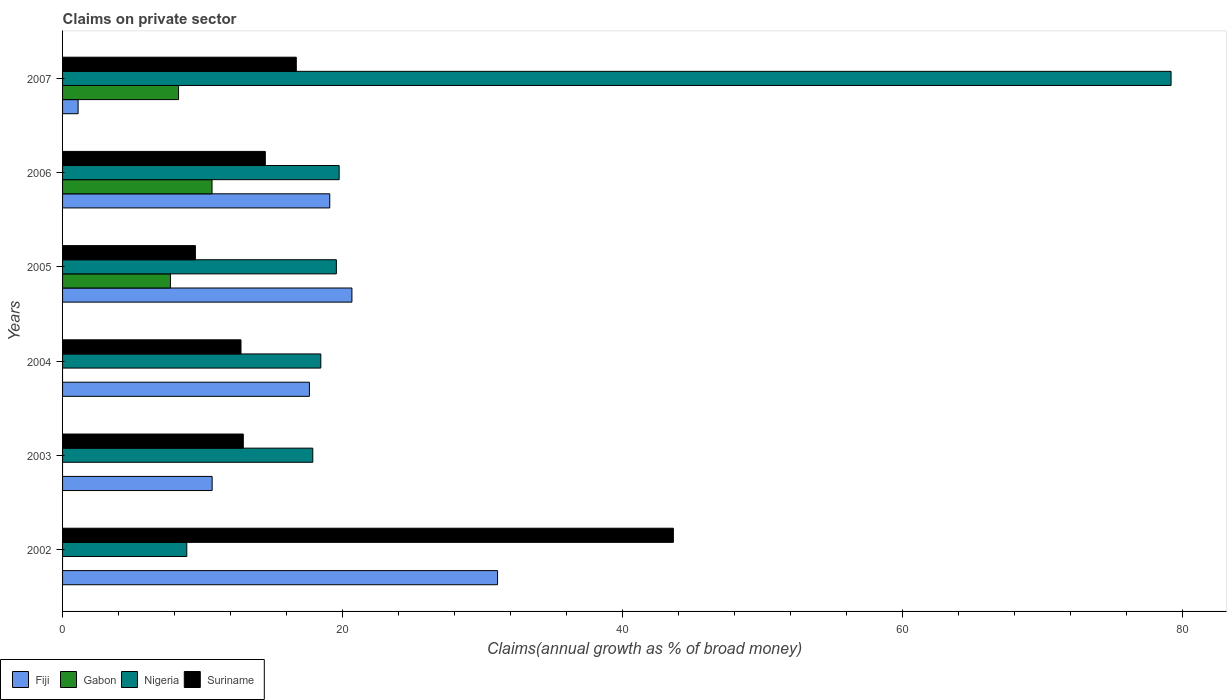How many different coloured bars are there?
Provide a short and direct response. 4. How many groups of bars are there?
Make the answer very short. 6. Are the number of bars per tick equal to the number of legend labels?
Ensure brevity in your answer.  No. Are the number of bars on each tick of the Y-axis equal?
Offer a very short reply. No. What is the percentage of broad money claimed on private sector in Suriname in 2007?
Give a very brief answer. 16.69. Across all years, what is the maximum percentage of broad money claimed on private sector in Fiji?
Offer a terse response. 31.07. Across all years, what is the minimum percentage of broad money claimed on private sector in Gabon?
Provide a short and direct response. 0. What is the total percentage of broad money claimed on private sector in Fiji in the graph?
Your answer should be very brief. 100.24. What is the difference between the percentage of broad money claimed on private sector in Fiji in 2004 and that in 2006?
Make the answer very short. -1.45. What is the difference between the percentage of broad money claimed on private sector in Suriname in 2003 and the percentage of broad money claimed on private sector in Fiji in 2002?
Keep it short and to the point. -18.16. What is the average percentage of broad money claimed on private sector in Suriname per year?
Make the answer very short. 18.32. In the year 2006, what is the difference between the percentage of broad money claimed on private sector in Fiji and percentage of broad money claimed on private sector in Suriname?
Provide a succinct answer. 4.6. What is the ratio of the percentage of broad money claimed on private sector in Suriname in 2005 to that in 2007?
Keep it short and to the point. 0.57. Is the percentage of broad money claimed on private sector in Suriname in 2006 less than that in 2007?
Your answer should be very brief. Yes. Is the difference between the percentage of broad money claimed on private sector in Fiji in 2003 and 2004 greater than the difference between the percentage of broad money claimed on private sector in Suriname in 2003 and 2004?
Provide a succinct answer. No. What is the difference between the highest and the second highest percentage of broad money claimed on private sector in Gabon?
Keep it short and to the point. 2.39. What is the difference between the highest and the lowest percentage of broad money claimed on private sector in Gabon?
Make the answer very short. 10.68. Is it the case that in every year, the sum of the percentage of broad money claimed on private sector in Fiji and percentage of broad money claimed on private sector in Nigeria is greater than the sum of percentage of broad money claimed on private sector in Suriname and percentage of broad money claimed on private sector in Gabon?
Give a very brief answer. Yes. How many bars are there?
Your answer should be compact. 21. How many years are there in the graph?
Your answer should be compact. 6. What is the difference between two consecutive major ticks on the X-axis?
Give a very brief answer. 20. Are the values on the major ticks of X-axis written in scientific E-notation?
Offer a terse response. No. How many legend labels are there?
Your response must be concise. 4. How are the legend labels stacked?
Provide a succinct answer. Horizontal. What is the title of the graph?
Make the answer very short. Claims on private sector. Does "Jamaica" appear as one of the legend labels in the graph?
Ensure brevity in your answer.  No. What is the label or title of the X-axis?
Offer a very short reply. Claims(annual growth as % of broad money). What is the label or title of the Y-axis?
Provide a succinct answer. Years. What is the Claims(annual growth as % of broad money) in Fiji in 2002?
Ensure brevity in your answer.  31.07. What is the Claims(annual growth as % of broad money) in Gabon in 2002?
Your response must be concise. 0. What is the Claims(annual growth as % of broad money) in Nigeria in 2002?
Your response must be concise. 8.87. What is the Claims(annual growth as % of broad money) in Suriname in 2002?
Ensure brevity in your answer.  43.63. What is the Claims(annual growth as % of broad money) in Fiji in 2003?
Make the answer very short. 10.68. What is the Claims(annual growth as % of broad money) in Nigeria in 2003?
Your answer should be very brief. 17.87. What is the Claims(annual growth as % of broad money) of Suriname in 2003?
Your answer should be compact. 12.91. What is the Claims(annual growth as % of broad money) of Fiji in 2004?
Your answer should be compact. 17.63. What is the Claims(annual growth as % of broad money) of Nigeria in 2004?
Your response must be concise. 18.44. What is the Claims(annual growth as % of broad money) of Suriname in 2004?
Keep it short and to the point. 12.74. What is the Claims(annual growth as % of broad money) of Fiji in 2005?
Provide a succinct answer. 20.67. What is the Claims(annual growth as % of broad money) of Gabon in 2005?
Your response must be concise. 7.7. What is the Claims(annual growth as % of broad money) of Nigeria in 2005?
Make the answer very short. 19.56. What is the Claims(annual growth as % of broad money) of Suriname in 2005?
Provide a short and direct response. 9.49. What is the Claims(annual growth as % of broad money) of Fiji in 2006?
Offer a very short reply. 19.09. What is the Claims(annual growth as % of broad money) in Gabon in 2006?
Make the answer very short. 10.68. What is the Claims(annual growth as % of broad money) of Nigeria in 2006?
Your answer should be very brief. 19.76. What is the Claims(annual growth as % of broad money) in Suriname in 2006?
Give a very brief answer. 14.48. What is the Claims(annual growth as % of broad money) of Fiji in 2007?
Provide a succinct answer. 1.11. What is the Claims(annual growth as % of broad money) in Gabon in 2007?
Ensure brevity in your answer.  8.28. What is the Claims(annual growth as % of broad money) of Nigeria in 2007?
Ensure brevity in your answer.  79.17. What is the Claims(annual growth as % of broad money) in Suriname in 2007?
Make the answer very short. 16.69. Across all years, what is the maximum Claims(annual growth as % of broad money) of Fiji?
Ensure brevity in your answer.  31.07. Across all years, what is the maximum Claims(annual growth as % of broad money) in Gabon?
Offer a very short reply. 10.68. Across all years, what is the maximum Claims(annual growth as % of broad money) in Nigeria?
Ensure brevity in your answer.  79.17. Across all years, what is the maximum Claims(annual growth as % of broad money) of Suriname?
Give a very brief answer. 43.63. Across all years, what is the minimum Claims(annual growth as % of broad money) in Fiji?
Provide a short and direct response. 1.11. Across all years, what is the minimum Claims(annual growth as % of broad money) of Gabon?
Offer a very short reply. 0. Across all years, what is the minimum Claims(annual growth as % of broad money) in Nigeria?
Your answer should be compact. 8.87. Across all years, what is the minimum Claims(annual growth as % of broad money) of Suriname?
Your answer should be very brief. 9.49. What is the total Claims(annual growth as % of broad money) in Fiji in the graph?
Offer a very short reply. 100.24. What is the total Claims(annual growth as % of broad money) of Gabon in the graph?
Offer a very short reply. 26.66. What is the total Claims(annual growth as % of broad money) in Nigeria in the graph?
Ensure brevity in your answer.  163.68. What is the total Claims(annual growth as % of broad money) in Suriname in the graph?
Offer a terse response. 109.94. What is the difference between the Claims(annual growth as % of broad money) of Fiji in 2002 and that in 2003?
Offer a terse response. 20.39. What is the difference between the Claims(annual growth as % of broad money) of Nigeria in 2002 and that in 2003?
Offer a very short reply. -9. What is the difference between the Claims(annual growth as % of broad money) of Suriname in 2002 and that in 2003?
Provide a short and direct response. 30.72. What is the difference between the Claims(annual growth as % of broad money) of Fiji in 2002 and that in 2004?
Offer a terse response. 13.44. What is the difference between the Claims(annual growth as % of broad money) of Nigeria in 2002 and that in 2004?
Your response must be concise. -9.57. What is the difference between the Claims(annual growth as % of broad money) in Suriname in 2002 and that in 2004?
Give a very brief answer. 30.88. What is the difference between the Claims(annual growth as % of broad money) in Fiji in 2002 and that in 2005?
Offer a very short reply. 10.4. What is the difference between the Claims(annual growth as % of broad money) of Nigeria in 2002 and that in 2005?
Offer a terse response. -10.68. What is the difference between the Claims(annual growth as % of broad money) in Suriname in 2002 and that in 2005?
Make the answer very short. 34.14. What is the difference between the Claims(annual growth as % of broad money) in Fiji in 2002 and that in 2006?
Provide a succinct answer. 11.98. What is the difference between the Claims(annual growth as % of broad money) in Nigeria in 2002 and that in 2006?
Provide a succinct answer. -10.88. What is the difference between the Claims(annual growth as % of broad money) of Suriname in 2002 and that in 2006?
Ensure brevity in your answer.  29.15. What is the difference between the Claims(annual growth as % of broad money) of Fiji in 2002 and that in 2007?
Offer a very short reply. 29.96. What is the difference between the Claims(annual growth as % of broad money) of Nigeria in 2002 and that in 2007?
Offer a terse response. -70.3. What is the difference between the Claims(annual growth as % of broad money) of Suriname in 2002 and that in 2007?
Ensure brevity in your answer.  26.93. What is the difference between the Claims(annual growth as % of broad money) of Fiji in 2003 and that in 2004?
Your answer should be very brief. -6.95. What is the difference between the Claims(annual growth as % of broad money) of Nigeria in 2003 and that in 2004?
Give a very brief answer. -0.57. What is the difference between the Claims(annual growth as % of broad money) in Suriname in 2003 and that in 2004?
Keep it short and to the point. 0.17. What is the difference between the Claims(annual growth as % of broad money) of Fiji in 2003 and that in 2005?
Your response must be concise. -9.98. What is the difference between the Claims(annual growth as % of broad money) of Nigeria in 2003 and that in 2005?
Your answer should be very brief. -1.68. What is the difference between the Claims(annual growth as % of broad money) in Suriname in 2003 and that in 2005?
Your answer should be very brief. 3.42. What is the difference between the Claims(annual growth as % of broad money) in Fiji in 2003 and that in 2006?
Make the answer very short. -8.4. What is the difference between the Claims(annual growth as % of broad money) in Nigeria in 2003 and that in 2006?
Provide a short and direct response. -1.89. What is the difference between the Claims(annual growth as % of broad money) in Suriname in 2003 and that in 2006?
Provide a short and direct response. -1.57. What is the difference between the Claims(annual growth as % of broad money) of Fiji in 2003 and that in 2007?
Your answer should be compact. 9.57. What is the difference between the Claims(annual growth as % of broad money) in Nigeria in 2003 and that in 2007?
Make the answer very short. -61.3. What is the difference between the Claims(annual growth as % of broad money) in Suriname in 2003 and that in 2007?
Your answer should be very brief. -3.78. What is the difference between the Claims(annual growth as % of broad money) of Fiji in 2004 and that in 2005?
Keep it short and to the point. -3.04. What is the difference between the Claims(annual growth as % of broad money) of Nigeria in 2004 and that in 2005?
Make the answer very short. -1.11. What is the difference between the Claims(annual growth as % of broad money) of Suriname in 2004 and that in 2005?
Make the answer very short. 3.26. What is the difference between the Claims(annual growth as % of broad money) in Fiji in 2004 and that in 2006?
Keep it short and to the point. -1.45. What is the difference between the Claims(annual growth as % of broad money) in Nigeria in 2004 and that in 2006?
Keep it short and to the point. -1.31. What is the difference between the Claims(annual growth as % of broad money) in Suriname in 2004 and that in 2006?
Make the answer very short. -1.74. What is the difference between the Claims(annual growth as % of broad money) of Fiji in 2004 and that in 2007?
Make the answer very short. 16.52. What is the difference between the Claims(annual growth as % of broad money) in Nigeria in 2004 and that in 2007?
Your response must be concise. -60.73. What is the difference between the Claims(annual growth as % of broad money) of Suriname in 2004 and that in 2007?
Ensure brevity in your answer.  -3.95. What is the difference between the Claims(annual growth as % of broad money) of Fiji in 2005 and that in 2006?
Make the answer very short. 1.58. What is the difference between the Claims(annual growth as % of broad money) in Gabon in 2005 and that in 2006?
Provide a succinct answer. -2.97. What is the difference between the Claims(annual growth as % of broad money) in Nigeria in 2005 and that in 2006?
Give a very brief answer. -0.2. What is the difference between the Claims(annual growth as % of broad money) in Suriname in 2005 and that in 2006?
Ensure brevity in your answer.  -4.99. What is the difference between the Claims(annual growth as % of broad money) in Fiji in 2005 and that in 2007?
Offer a very short reply. 19.56. What is the difference between the Claims(annual growth as % of broad money) of Gabon in 2005 and that in 2007?
Provide a short and direct response. -0.58. What is the difference between the Claims(annual growth as % of broad money) in Nigeria in 2005 and that in 2007?
Your response must be concise. -59.62. What is the difference between the Claims(annual growth as % of broad money) in Suriname in 2005 and that in 2007?
Provide a succinct answer. -7.21. What is the difference between the Claims(annual growth as % of broad money) in Fiji in 2006 and that in 2007?
Keep it short and to the point. 17.98. What is the difference between the Claims(annual growth as % of broad money) in Gabon in 2006 and that in 2007?
Your response must be concise. 2.39. What is the difference between the Claims(annual growth as % of broad money) of Nigeria in 2006 and that in 2007?
Offer a terse response. -59.42. What is the difference between the Claims(annual growth as % of broad money) in Suriname in 2006 and that in 2007?
Provide a succinct answer. -2.21. What is the difference between the Claims(annual growth as % of broad money) of Fiji in 2002 and the Claims(annual growth as % of broad money) of Nigeria in 2003?
Your response must be concise. 13.2. What is the difference between the Claims(annual growth as % of broad money) of Fiji in 2002 and the Claims(annual growth as % of broad money) of Suriname in 2003?
Make the answer very short. 18.16. What is the difference between the Claims(annual growth as % of broad money) of Nigeria in 2002 and the Claims(annual growth as % of broad money) of Suriname in 2003?
Provide a succinct answer. -4.04. What is the difference between the Claims(annual growth as % of broad money) in Fiji in 2002 and the Claims(annual growth as % of broad money) in Nigeria in 2004?
Your response must be concise. 12.62. What is the difference between the Claims(annual growth as % of broad money) of Fiji in 2002 and the Claims(annual growth as % of broad money) of Suriname in 2004?
Make the answer very short. 18.33. What is the difference between the Claims(annual growth as % of broad money) in Nigeria in 2002 and the Claims(annual growth as % of broad money) in Suriname in 2004?
Your answer should be very brief. -3.87. What is the difference between the Claims(annual growth as % of broad money) in Fiji in 2002 and the Claims(annual growth as % of broad money) in Gabon in 2005?
Your answer should be very brief. 23.36. What is the difference between the Claims(annual growth as % of broad money) of Fiji in 2002 and the Claims(annual growth as % of broad money) of Nigeria in 2005?
Your answer should be very brief. 11.51. What is the difference between the Claims(annual growth as % of broad money) in Fiji in 2002 and the Claims(annual growth as % of broad money) in Suriname in 2005?
Provide a succinct answer. 21.58. What is the difference between the Claims(annual growth as % of broad money) in Nigeria in 2002 and the Claims(annual growth as % of broad money) in Suriname in 2005?
Offer a very short reply. -0.61. What is the difference between the Claims(annual growth as % of broad money) in Fiji in 2002 and the Claims(annual growth as % of broad money) in Gabon in 2006?
Your response must be concise. 20.39. What is the difference between the Claims(annual growth as % of broad money) of Fiji in 2002 and the Claims(annual growth as % of broad money) of Nigeria in 2006?
Offer a very short reply. 11.31. What is the difference between the Claims(annual growth as % of broad money) of Fiji in 2002 and the Claims(annual growth as % of broad money) of Suriname in 2006?
Your answer should be compact. 16.59. What is the difference between the Claims(annual growth as % of broad money) of Nigeria in 2002 and the Claims(annual growth as % of broad money) of Suriname in 2006?
Your answer should be compact. -5.61. What is the difference between the Claims(annual growth as % of broad money) in Fiji in 2002 and the Claims(annual growth as % of broad money) in Gabon in 2007?
Give a very brief answer. 22.78. What is the difference between the Claims(annual growth as % of broad money) in Fiji in 2002 and the Claims(annual growth as % of broad money) in Nigeria in 2007?
Provide a succinct answer. -48.11. What is the difference between the Claims(annual growth as % of broad money) of Fiji in 2002 and the Claims(annual growth as % of broad money) of Suriname in 2007?
Keep it short and to the point. 14.37. What is the difference between the Claims(annual growth as % of broad money) in Nigeria in 2002 and the Claims(annual growth as % of broad money) in Suriname in 2007?
Offer a very short reply. -7.82. What is the difference between the Claims(annual growth as % of broad money) in Fiji in 2003 and the Claims(annual growth as % of broad money) in Nigeria in 2004?
Offer a terse response. -7.76. What is the difference between the Claims(annual growth as % of broad money) of Fiji in 2003 and the Claims(annual growth as % of broad money) of Suriname in 2004?
Provide a short and direct response. -2.06. What is the difference between the Claims(annual growth as % of broad money) of Nigeria in 2003 and the Claims(annual growth as % of broad money) of Suriname in 2004?
Your answer should be very brief. 5.13. What is the difference between the Claims(annual growth as % of broad money) in Fiji in 2003 and the Claims(annual growth as % of broad money) in Gabon in 2005?
Your answer should be very brief. 2.98. What is the difference between the Claims(annual growth as % of broad money) in Fiji in 2003 and the Claims(annual growth as % of broad money) in Nigeria in 2005?
Provide a succinct answer. -8.87. What is the difference between the Claims(annual growth as % of broad money) of Fiji in 2003 and the Claims(annual growth as % of broad money) of Suriname in 2005?
Provide a succinct answer. 1.2. What is the difference between the Claims(annual growth as % of broad money) of Nigeria in 2003 and the Claims(annual growth as % of broad money) of Suriname in 2005?
Offer a terse response. 8.38. What is the difference between the Claims(annual growth as % of broad money) of Fiji in 2003 and the Claims(annual growth as % of broad money) of Gabon in 2006?
Provide a short and direct response. 0.01. What is the difference between the Claims(annual growth as % of broad money) of Fiji in 2003 and the Claims(annual growth as % of broad money) of Nigeria in 2006?
Offer a terse response. -9.07. What is the difference between the Claims(annual growth as % of broad money) in Fiji in 2003 and the Claims(annual growth as % of broad money) in Suriname in 2006?
Your answer should be compact. -3.8. What is the difference between the Claims(annual growth as % of broad money) in Nigeria in 2003 and the Claims(annual growth as % of broad money) in Suriname in 2006?
Ensure brevity in your answer.  3.39. What is the difference between the Claims(annual growth as % of broad money) in Fiji in 2003 and the Claims(annual growth as % of broad money) in Gabon in 2007?
Ensure brevity in your answer.  2.4. What is the difference between the Claims(annual growth as % of broad money) of Fiji in 2003 and the Claims(annual growth as % of broad money) of Nigeria in 2007?
Give a very brief answer. -68.49. What is the difference between the Claims(annual growth as % of broad money) in Fiji in 2003 and the Claims(annual growth as % of broad money) in Suriname in 2007?
Ensure brevity in your answer.  -6.01. What is the difference between the Claims(annual growth as % of broad money) in Nigeria in 2003 and the Claims(annual growth as % of broad money) in Suriname in 2007?
Your response must be concise. 1.18. What is the difference between the Claims(annual growth as % of broad money) of Fiji in 2004 and the Claims(annual growth as % of broad money) of Gabon in 2005?
Offer a terse response. 9.93. What is the difference between the Claims(annual growth as % of broad money) in Fiji in 2004 and the Claims(annual growth as % of broad money) in Nigeria in 2005?
Keep it short and to the point. -1.92. What is the difference between the Claims(annual growth as % of broad money) of Fiji in 2004 and the Claims(annual growth as % of broad money) of Suriname in 2005?
Make the answer very short. 8.14. What is the difference between the Claims(annual growth as % of broad money) of Nigeria in 2004 and the Claims(annual growth as % of broad money) of Suriname in 2005?
Your answer should be very brief. 8.96. What is the difference between the Claims(annual growth as % of broad money) in Fiji in 2004 and the Claims(annual growth as % of broad money) in Gabon in 2006?
Provide a short and direct response. 6.96. What is the difference between the Claims(annual growth as % of broad money) of Fiji in 2004 and the Claims(annual growth as % of broad money) of Nigeria in 2006?
Ensure brevity in your answer.  -2.13. What is the difference between the Claims(annual growth as % of broad money) in Fiji in 2004 and the Claims(annual growth as % of broad money) in Suriname in 2006?
Your answer should be very brief. 3.15. What is the difference between the Claims(annual growth as % of broad money) in Nigeria in 2004 and the Claims(annual growth as % of broad money) in Suriname in 2006?
Your answer should be very brief. 3.96. What is the difference between the Claims(annual growth as % of broad money) in Fiji in 2004 and the Claims(annual growth as % of broad money) in Gabon in 2007?
Provide a short and direct response. 9.35. What is the difference between the Claims(annual growth as % of broad money) in Fiji in 2004 and the Claims(annual growth as % of broad money) in Nigeria in 2007?
Give a very brief answer. -61.54. What is the difference between the Claims(annual growth as % of broad money) of Fiji in 2004 and the Claims(annual growth as % of broad money) of Suriname in 2007?
Your response must be concise. 0.94. What is the difference between the Claims(annual growth as % of broad money) of Nigeria in 2004 and the Claims(annual growth as % of broad money) of Suriname in 2007?
Keep it short and to the point. 1.75. What is the difference between the Claims(annual growth as % of broad money) of Fiji in 2005 and the Claims(annual growth as % of broad money) of Gabon in 2006?
Offer a very short reply. 9.99. What is the difference between the Claims(annual growth as % of broad money) in Fiji in 2005 and the Claims(annual growth as % of broad money) in Nigeria in 2006?
Keep it short and to the point. 0.91. What is the difference between the Claims(annual growth as % of broad money) of Fiji in 2005 and the Claims(annual growth as % of broad money) of Suriname in 2006?
Ensure brevity in your answer.  6.19. What is the difference between the Claims(annual growth as % of broad money) in Gabon in 2005 and the Claims(annual growth as % of broad money) in Nigeria in 2006?
Provide a succinct answer. -12.05. What is the difference between the Claims(annual growth as % of broad money) in Gabon in 2005 and the Claims(annual growth as % of broad money) in Suriname in 2006?
Ensure brevity in your answer.  -6.78. What is the difference between the Claims(annual growth as % of broad money) of Nigeria in 2005 and the Claims(annual growth as % of broad money) of Suriname in 2006?
Ensure brevity in your answer.  5.07. What is the difference between the Claims(annual growth as % of broad money) of Fiji in 2005 and the Claims(annual growth as % of broad money) of Gabon in 2007?
Give a very brief answer. 12.38. What is the difference between the Claims(annual growth as % of broad money) in Fiji in 2005 and the Claims(annual growth as % of broad money) in Nigeria in 2007?
Give a very brief answer. -58.51. What is the difference between the Claims(annual growth as % of broad money) of Fiji in 2005 and the Claims(annual growth as % of broad money) of Suriname in 2007?
Make the answer very short. 3.97. What is the difference between the Claims(annual growth as % of broad money) of Gabon in 2005 and the Claims(annual growth as % of broad money) of Nigeria in 2007?
Give a very brief answer. -71.47. What is the difference between the Claims(annual growth as % of broad money) of Gabon in 2005 and the Claims(annual growth as % of broad money) of Suriname in 2007?
Offer a terse response. -8.99. What is the difference between the Claims(annual growth as % of broad money) of Nigeria in 2005 and the Claims(annual growth as % of broad money) of Suriname in 2007?
Your answer should be very brief. 2.86. What is the difference between the Claims(annual growth as % of broad money) of Fiji in 2006 and the Claims(annual growth as % of broad money) of Gabon in 2007?
Your answer should be compact. 10.8. What is the difference between the Claims(annual growth as % of broad money) of Fiji in 2006 and the Claims(annual growth as % of broad money) of Nigeria in 2007?
Provide a short and direct response. -60.09. What is the difference between the Claims(annual growth as % of broad money) of Fiji in 2006 and the Claims(annual growth as % of broad money) of Suriname in 2007?
Make the answer very short. 2.39. What is the difference between the Claims(annual growth as % of broad money) of Gabon in 2006 and the Claims(annual growth as % of broad money) of Nigeria in 2007?
Offer a very short reply. -68.5. What is the difference between the Claims(annual growth as % of broad money) in Gabon in 2006 and the Claims(annual growth as % of broad money) in Suriname in 2007?
Provide a succinct answer. -6.02. What is the difference between the Claims(annual growth as % of broad money) in Nigeria in 2006 and the Claims(annual growth as % of broad money) in Suriname in 2007?
Provide a succinct answer. 3.06. What is the average Claims(annual growth as % of broad money) in Fiji per year?
Provide a succinct answer. 16.71. What is the average Claims(annual growth as % of broad money) in Gabon per year?
Provide a succinct answer. 4.44. What is the average Claims(annual growth as % of broad money) in Nigeria per year?
Your answer should be compact. 27.28. What is the average Claims(annual growth as % of broad money) of Suriname per year?
Offer a very short reply. 18.32. In the year 2002, what is the difference between the Claims(annual growth as % of broad money) in Fiji and Claims(annual growth as % of broad money) in Nigeria?
Make the answer very short. 22.2. In the year 2002, what is the difference between the Claims(annual growth as % of broad money) of Fiji and Claims(annual growth as % of broad money) of Suriname?
Your answer should be very brief. -12.56. In the year 2002, what is the difference between the Claims(annual growth as % of broad money) of Nigeria and Claims(annual growth as % of broad money) of Suriname?
Your answer should be compact. -34.75. In the year 2003, what is the difference between the Claims(annual growth as % of broad money) of Fiji and Claims(annual growth as % of broad money) of Nigeria?
Your answer should be very brief. -7.19. In the year 2003, what is the difference between the Claims(annual growth as % of broad money) in Fiji and Claims(annual growth as % of broad money) in Suriname?
Make the answer very short. -2.23. In the year 2003, what is the difference between the Claims(annual growth as % of broad money) of Nigeria and Claims(annual growth as % of broad money) of Suriname?
Your answer should be very brief. 4.96. In the year 2004, what is the difference between the Claims(annual growth as % of broad money) of Fiji and Claims(annual growth as % of broad money) of Nigeria?
Your answer should be very brief. -0.81. In the year 2004, what is the difference between the Claims(annual growth as % of broad money) in Fiji and Claims(annual growth as % of broad money) in Suriname?
Keep it short and to the point. 4.89. In the year 2004, what is the difference between the Claims(annual growth as % of broad money) of Nigeria and Claims(annual growth as % of broad money) of Suriname?
Offer a very short reply. 5.7. In the year 2005, what is the difference between the Claims(annual growth as % of broad money) in Fiji and Claims(annual growth as % of broad money) in Gabon?
Offer a very short reply. 12.96. In the year 2005, what is the difference between the Claims(annual growth as % of broad money) in Fiji and Claims(annual growth as % of broad money) in Nigeria?
Keep it short and to the point. 1.11. In the year 2005, what is the difference between the Claims(annual growth as % of broad money) of Fiji and Claims(annual growth as % of broad money) of Suriname?
Your response must be concise. 11.18. In the year 2005, what is the difference between the Claims(annual growth as % of broad money) in Gabon and Claims(annual growth as % of broad money) in Nigeria?
Ensure brevity in your answer.  -11.85. In the year 2005, what is the difference between the Claims(annual growth as % of broad money) in Gabon and Claims(annual growth as % of broad money) in Suriname?
Make the answer very short. -1.78. In the year 2005, what is the difference between the Claims(annual growth as % of broad money) of Nigeria and Claims(annual growth as % of broad money) of Suriname?
Give a very brief answer. 10.07. In the year 2006, what is the difference between the Claims(annual growth as % of broad money) in Fiji and Claims(annual growth as % of broad money) in Gabon?
Give a very brief answer. 8.41. In the year 2006, what is the difference between the Claims(annual growth as % of broad money) in Fiji and Claims(annual growth as % of broad money) in Nigeria?
Offer a terse response. -0.67. In the year 2006, what is the difference between the Claims(annual growth as % of broad money) of Fiji and Claims(annual growth as % of broad money) of Suriname?
Your answer should be compact. 4.6. In the year 2006, what is the difference between the Claims(annual growth as % of broad money) of Gabon and Claims(annual growth as % of broad money) of Nigeria?
Ensure brevity in your answer.  -9.08. In the year 2006, what is the difference between the Claims(annual growth as % of broad money) of Gabon and Claims(annual growth as % of broad money) of Suriname?
Provide a short and direct response. -3.81. In the year 2006, what is the difference between the Claims(annual growth as % of broad money) of Nigeria and Claims(annual growth as % of broad money) of Suriname?
Offer a terse response. 5.28. In the year 2007, what is the difference between the Claims(annual growth as % of broad money) in Fiji and Claims(annual growth as % of broad money) in Gabon?
Give a very brief answer. -7.17. In the year 2007, what is the difference between the Claims(annual growth as % of broad money) of Fiji and Claims(annual growth as % of broad money) of Nigeria?
Make the answer very short. -78.06. In the year 2007, what is the difference between the Claims(annual growth as % of broad money) of Fiji and Claims(annual growth as % of broad money) of Suriname?
Keep it short and to the point. -15.58. In the year 2007, what is the difference between the Claims(annual growth as % of broad money) of Gabon and Claims(annual growth as % of broad money) of Nigeria?
Offer a very short reply. -70.89. In the year 2007, what is the difference between the Claims(annual growth as % of broad money) in Gabon and Claims(annual growth as % of broad money) in Suriname?
Make the answer very short. -8.41. In the year 2007, what is the difference between the Claims(annual growth as % of broad money) in Nigeria and Claims(annual growth as % of broad money) in Suriname?
Make the answer very short. 62.48. What is the ratio of the Claims(annual growth as % of broad money) in Fiji in 2002 to that in 2003?
Provide a short and direct response. 2.91. What is the ratio of the Claims(annual growth as % of broad money) of Nigeria in 2002 to that in 2003?
Ensure brevity in your answer.  0.5. What is the ratio of the Claims(annual growth as % of broad money) in Suriname in 2002 to that in 2003?
Provide a short and direct response. 3.38. What is the ratio of the Claims(annual growth as % of broad money) in Fiji in 2002 to that in 2004?
Your response must be concise. 1.76. What is the ratio of the Claims(annual growth as % of broad money) in Nigeria in 2002 to that in 2004?
Provide a succinct answer. 0.48. What is the ratio of the Claims(annual growth as % of broad money) in Suriname in 2002 to that in 2004?
Offer a terse response. 3.42. What is the ratio of the Claims(annual growth as % of broad money) in Fiji in 2002 to that in 2005?
Your response must be concise. 1.5. What is the ratio of the Claims(annual growth as % of broad money) in Nigeria in 2002 to that in 2005?
Your answer should be very brief. 0.45. What is the ratio of the Claims(annual growth as % of broad money) of Suriname in 2002 to that in 2005?
Offer a very short reply. 4.6. What is the ratio of the Claims(annual growth as % of broad money) of Fiji in 2002 to that in 2006?
Make the answer very short. 1.63. What is the ratio of the Claims(annual growth as % of broad money) in Nigeria in 2002 to that in 2006?
Offer a very short reply. 0.45. What is the ratio of the Claims(annual growth as % of broad money) in Suriname in 2002 to that in 2006?
Give a very brief answer. 3.01. What is the ratio of the Claims(annual growth as % of broad money) of Fiji in 2002 to that in 2007?
Ensure brevity in your answer.  27.99. What is the ratio of the Claims(annual growth as % of broad money) in Nigeria in 2002 to that in 2007?
Ensure brevity in your answer.  0.11. What is the ratio of the Claims(annual growth as % of broad money) of Suriname in 2002 to that in 2007?
Offer a very short reply. 2.61. What is the ratio of the Claims(annual growth as % of broad money) of Fiji in 2003 to that in 2004?
Your answer should be very brief. 0.61. What is the ratio of the Claims(annual growth as % of broad money) in Nigeria in 2003 to that in 2004?
Your answer should be compact. 0.97. What is the ratio of the Claims(annual growth as % of broad money) of Suriname in 2003 to that in 2004?
Your response must be concise. 1.01. What is the ratio of the Claims(annual growth as % of broad money) in Fiji in 2003 to that in 2005?
Give a very brief answer. 0.52. What is the ratio of the Claims(annual growth as % of broad money) in Nigeria in 2003 to that in 2005?
Offer a terse response. 0.91. What is the ratio of the Claims(annual growth as % of broad money) in Suriname in 2003 to that in 2005?
Your answer should be very brief. 1.36. What is the ratio of the Claims(annual growth as % of broad money) of Fiji in 2003 to that in 2006?
Your answer should be compact. 0.56. What is the ratio of the Claims(annual growth as % of broad money) of Nigeria in 2003 to that in 2006?
Offer a very short reply. 0.9. What is the ratio of the Claims(annual growth as % of broad money) of Suriname in 2003 to that in 2006?
Your response must be concise. 0.89. What is the ratio of the Claims(annual growth as % of broad money) in Fiji in 2003 to that in 2007?
Keep it short and to the point. 9.62. What is the ratio of the Claims(annual growth as % of broad money) of Nigeria in 2003 to that in 2007?
Offer a terse response. 0.23. What is the ratio of the Claims(annual growth as % of broad money) of Suriname in 2003 to that in 2007?
Your response must be concise. 0.77. What is the ratio of the Claims(annual growth as % of broad money) of Fiji in 2004 to that in 2005?
Keep it short and to the point. 0.85. What is the ratio of the Claims(annual growth as % of broad money) of Nigeria in 2004 to that in 2005?
Provide a short and direct response. 0.94. What is the ratio of the Claims(annual growth as % of broad money) of Suriname in 2004 to that in 2005?
Your answer should be very brief. 1.34. What is the ratio of the Claims(annual growth as % of broad money) in Fiji in 2004 to that in 2006?
Offer a terse response. 0.92. What is the ratio of the Claims(annual growth as % of broad money) of Nigeria in 2004 to that in 2006?
Make the answer very short. 0.93. What is the ratio of the Claims(annual growth as % of broad money) of Fiji in 2004 to that in 2007?
Your answer should be very brief. 15.88. What is the ratio of the Claims(annual growth as % of broad money) in Nigeria in 2004 to that in 2007?
Offer a very short reply. 0.23. What is the ratio of the Claims(annual growth as % of broad money) of Suriname in 2004 to that in 2007?
Your answer should be compact. 0.76. What is the ratio of the Claims(annual growth as % of broad money) in Fiji in 2005 to that in 2006?
Offer a very short reply. 1.08. What is the ratio of the Claims(annual growth as % of broad money) in Gabon in 2005 to that in 2006?
Make the answer very short. 0.72. What is the ratio of the Claims(annual growth as % of broad money) of Nigeria in 2005 to that in 2006?
Make the answer very short. 0.99. What is the ratio of the Claims(annual growth as % of broad money) in Suriname in 2005 to that in 2006?
Give a very brief answer. 0.66. What is the ratio of the Claims(annual growth as % of broad money) in Fiji in 2005 to that in 2007?
Provide a short and direct response. 18.62. What is the ratio of the Claims(annual growth as % of broad money) of Gabon in 2005 to that in 2007?
Your answer should be very brief. 0.93. What is the ratio of the Claims(annual growth as % of broad money) of Nigeria in 2005 to that in 2007?
Provide a short and direct response. 0.25. What is the ratio of the Claims(annual growth as % of broad money) of Suriname in 2005 to that in 2007?
Your answer should be very brief. 0.57. What is the ratio of the Claims(annual growth as % of broad money) of Fiji in 2006 to that in 2007?
Offer a terse response. 17.19. What is the ratio of the Claims(annual growth as % of broad money) in Gabon in 2006 to that in 2007?
Your answer should be very brief. 1.29. What is the ratio of the Claims(annual growth as % of broad money) in Nigeria in 2006 to that in 2007?
Your response must be concise. 0.25. What is the ratio of the Claims(annual growth as % of broad money) in Suriname in 2006 to that in 2007?
Your response must be concise. 0.87. What is the difference between the highest and the second highest Claims(annual growth as % of broad money) of Fiji?
Your response must be concise. 10.4. What is the difference between the highest and the second highest Claims(annual growth as % of broad money) of Gabon?
Your answer should be compact. 2.39. What is the difference between the highest and the second highest Claims(annual growth as % of broad money) of Nigeria?
Your answer should be very brief. 59.42. What is the difference between the highest and the second highest Claims(annual growth as % of broad money) in Suriname?
Offer a terse response. 26.93. What is the difference between the highest and the lowest Claims(annual growth as % of broad money) in Fiji?
Your answer should be very brief. 29.96. What is the difference between the highest and the lowest Claims(annual growth as % of broad money) of Gabon?
Your answer should be compact. 10.68. What is the difference between the highest and the lowest Claims(annual growth as % of broad money) in Nigeria?
Offer a very short reply. 70.3. What is the difference between the highest and the lowest Claims(annual growth as % of broad money) in Suriname?
Your response must be concise. 34.14. 